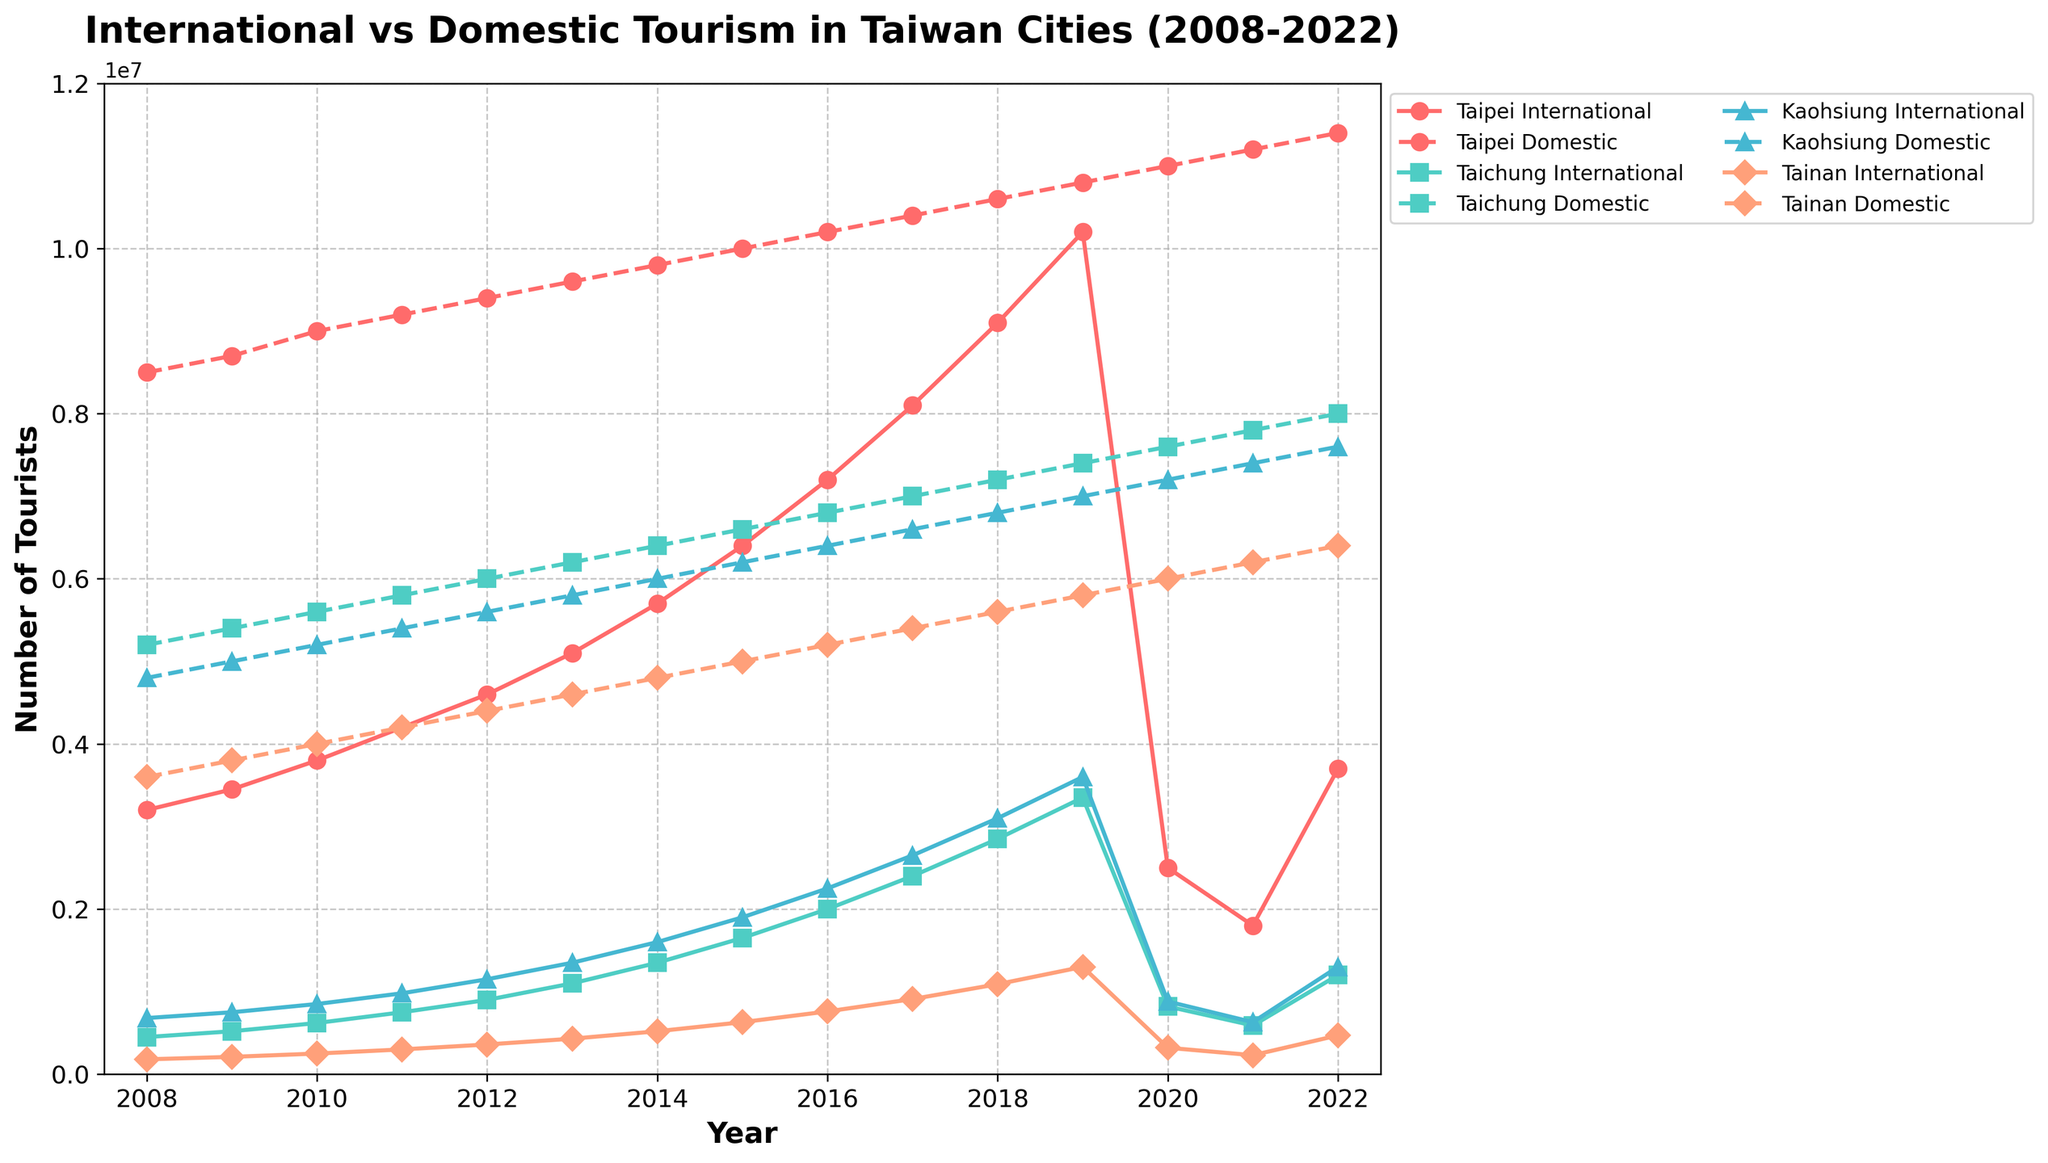What's the trend of domestic tourism in Taipei over the last 15 years? The line for Taipei Domestic tourists steadily increases from 8,500,000 in 2008 to 11,400,000 in 2022. This shows a continuous upward trend.
Answer: Steady increase In 2020, how much did the number of international tourists decline in Taipei compared to 2019? The number of international tourists in Taipei dropped from 10,200,000 in 2019 to 2,500,000 in 2020. The difference is 10,200,000 - 2,500,000 = 7,700,000.
Answer: 7,700,000 Which city had the highest number of domestic tourists in 2022, and how many? In 2022, Taipei had the highest number of domestic tourists with 11,400,000.
Answer: Taipei, 11,400,000 During which year did Kaohsiung see its highest number of international tourists and how many were there? Kaohsiung saw the highest number of international tourists in 2019, with a total of 3,600,000 tourists.
Answer: 2019, 3,600,000 Comparing Taichung's international and domestic tourism numbers in 2022, which type was greater and by how much? In 2022, Taichung had 1,200,000 international tourists and 8,000,000 domestic tourists. The domestic tourists were greater by 8,000,000 - 1,200,000 = 6,800,000.
Answer: Domestic, 6,800,000 By how much did the number of international tourists in Tainan increase from 2008 to 2019? The number of international tourists in Tainan increased from 180,000 in 2008 to 1,300,000 in 2019. The increase is 1,300,000 - 180,000 = 1,120,000.
Answer: 1,120,000 Which year shows the biggest gap between international and domestic tourists in Tainan, and what is the gap? In 2022, Tainan had 470,000 international tourists and 6,400,000 domestic tourists. The gap is 6,400,000 - 470,000 = 5,930,000, which is the largest gap.
Answer: 2022, 5,930,000 What was the difference in the number of international tourists between Taichung and Kaohsiung in 2013? In 2013, Taichung had 1,100,000 international tourists and Kaohsiung had 1,350,000. The difference is 1,350,000 - 1,100,000 = 250,000.
Answer: 250,000 In which year did Taipei first surpass 10,000,000 international tourists? Taipei first surpassed 10,000,000 international tourists in the year 2019.
Answer: 2019 